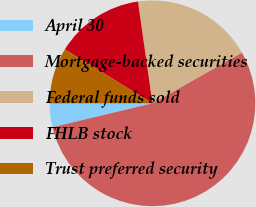Convert chart to OTSL. <chart><loc_0><loc_0><loc_500><loc_500><pie_chart><fcel>April 30<fcel>Mortgage-backed securities<fcel>Federal funds sold<fcel>FHLB stock<fcel>Trust preferred security<nl><fcel>3.72%<fcel>54.48%<fcel>19.04%<fcel>13.96%<fcel>8.8%<nl></chart> 